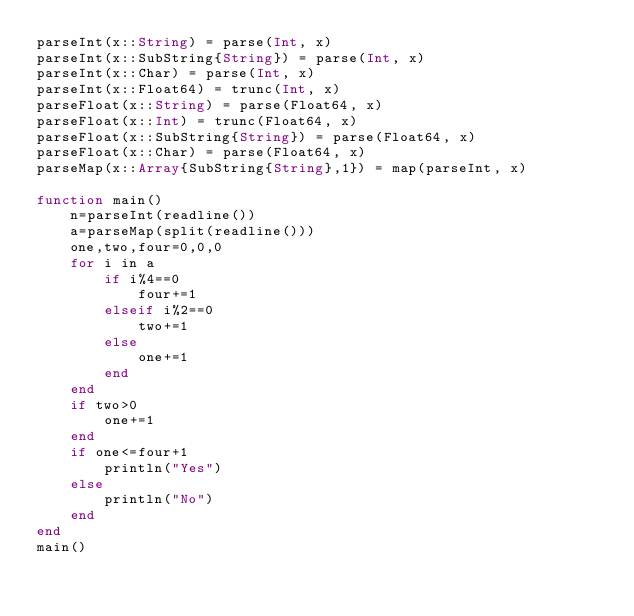Convert code to text. <code><loc_0><loc_0><loc_500><loc_500><_Julia_>parseInt(x::String) = parse(Int, x)
parseInt(x::SubString{String}) = parse(Int, x)
parseInt(x::Char) = parse(Int, x)
parseInt(x::Float64) = trunc(Int, x)
parseFloat(x::String) = parse(Float64, x)
parseFloat(x::Int) = trunc(Float64, x)
parseFloat(x::SubString{String}) = parse(Float64, x)
parseFloat(x::Char) = parse(Float64, x)
parseMap(x::Array{SubString{String},1}) = map(parseInt, x)

function main()
    n=parseInt(readline())
    a=parseMap(split(readline()))
    one,two,four=0,0,0
    for i in a
        if i%4==0
            four+=1
        elseif i%2==0
            two+=1
        else
            one+=1
        end
    end
    if two>0
        one+=1
    end
    if one<=four+1
        println("Yes")
    else
        println("No")
    end
end
main()</code> 